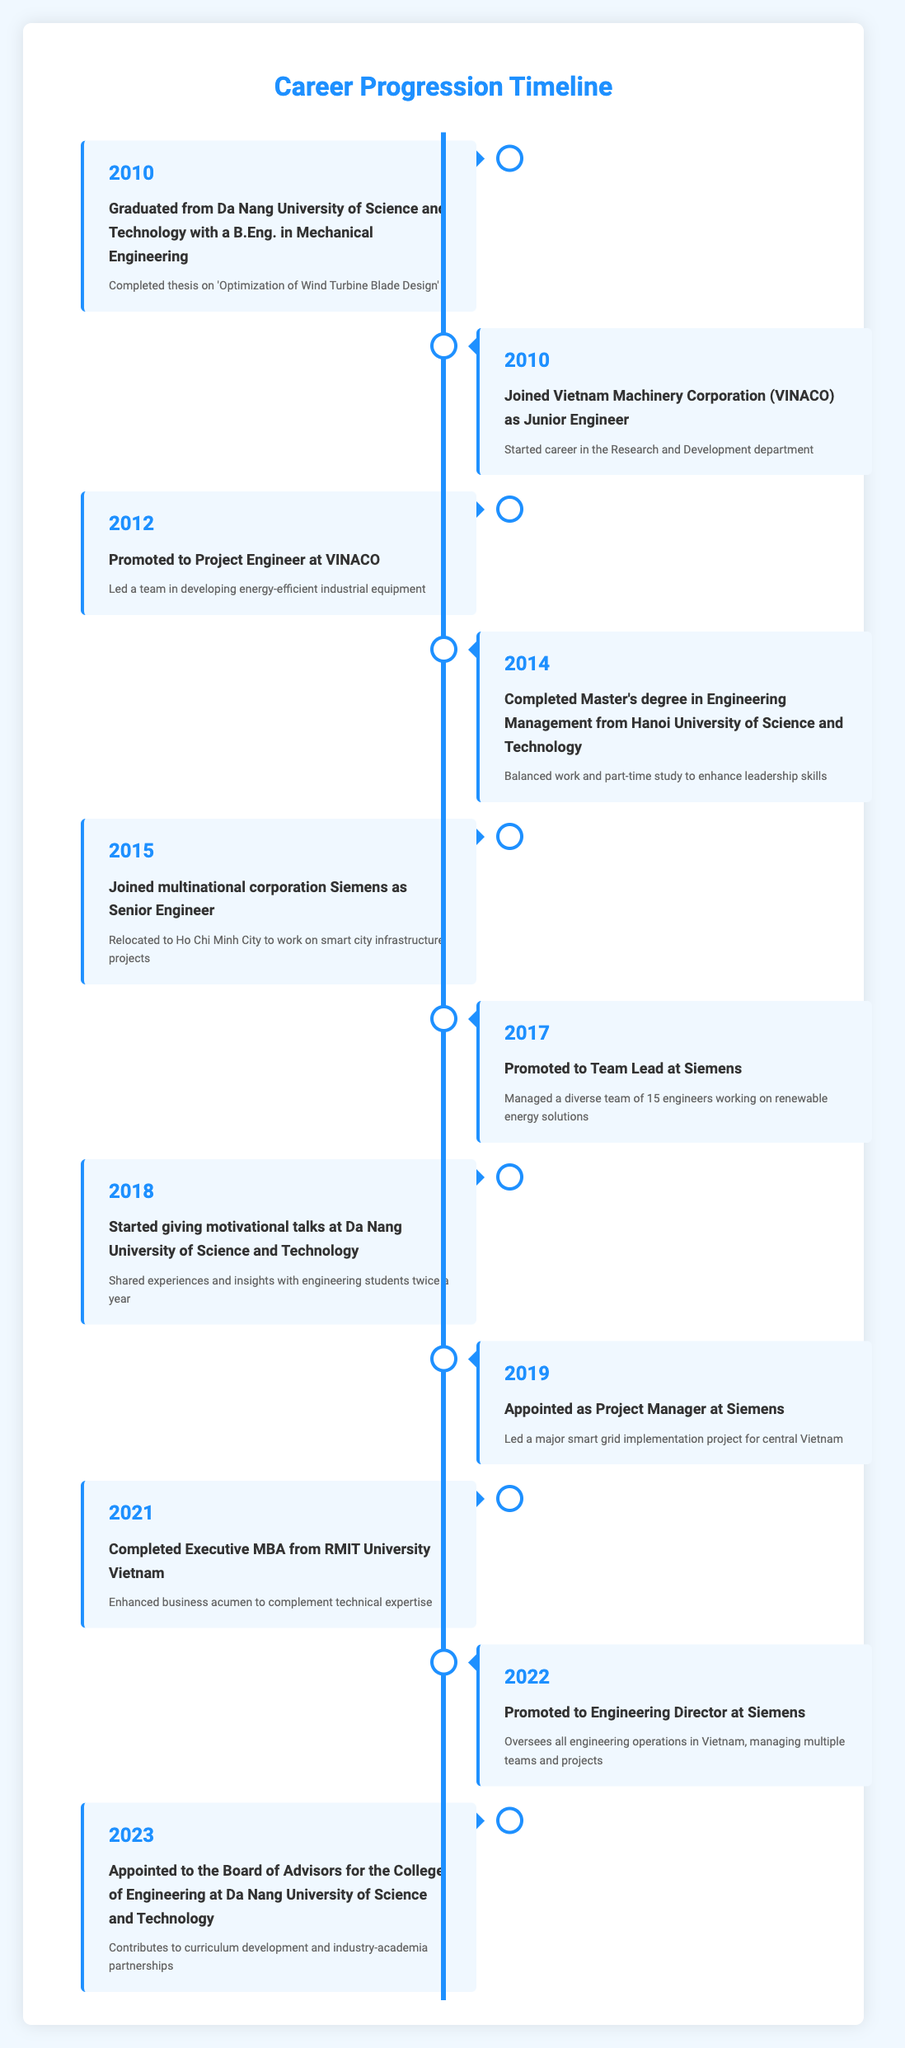What year did the engineer graduate from university? The timeline shows that the engineer graduated in 2010. This is indicated in the first entry of the table.
Answer: 2010 What was the engineer's first job after graduation? According to the timeline, the first job after graduation was as a Junior Engineer at Vietnam Machinery Corporation (VINACO), which occurred in the same year, 2010.
Answer: Junior Engineer at Vietnam Machinery Corporation (VINACO) How many years passed from the engineer's graduation to their promotion to Project Engineer? The engineer graduated in 2010 and was promoted to Project Engineer in 2012. Therefore, the time difference is 2012 - 2010, which equals 2 years.
Answer: 2 years In which year did the engineer complete their Executive MBA? The timeline indicates that the engineer completed their Executive MBA in 2021, as shown in the corresponding entry.
Answer: 2021 Was the engineer promoted to Team Lead before or after they joined Siemens? The engineer joined Siemens as a Senior Engineer in 2015 and was promoted to Team Lead in 2017, which means the promotion occurred after joining Siemens.
Answer: After How many roles did the engineer hold at Siemens before becoming Engineering Director? The engineer held three roles at Siemens: Senior Engineer, Team Lead, and Project Manager. The timeline details these positions from 2015 to 2022.
Answer: 3 roles What was the significant theme of the engineer's thesis upon graduation? The timeline notes that the engineer's thesis was on 'Optimization of Wind Turbine Blade Design', which is a specific area of research in mechanical engineering.
Answer: Optimization of Wind Turbine Blade Design Which degree was completed while balancing work and part-time study? The timeline specifies that the engineer completed a Master's degree in Engineering Management from Hanoi University of Science and Technology while working.
Answer: Master's degree in Engineering Management What is one of the contributions the engineer made after being appointed to the Board of Advisors in 2023? The timeline states that the engineer contributes to curriculum development and industry-academia partnerships, indicating involvement in educational improvements at the university.
Answer: Curriculum development and industry-academia partnerships 